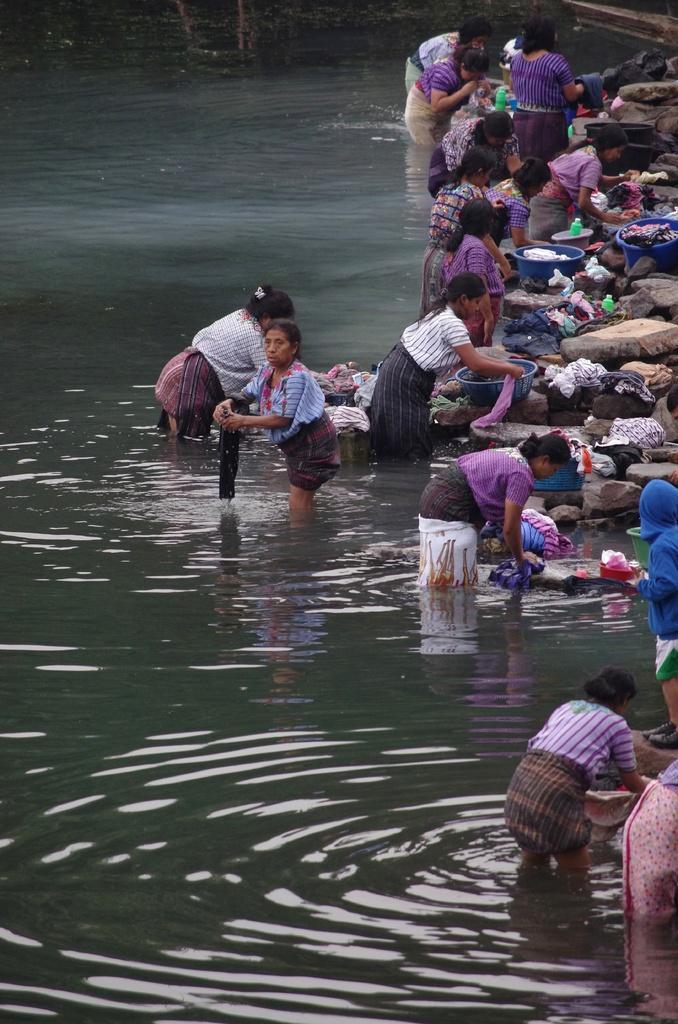How would you summarize this image in a sentence or two? In the picture we can see few women are washing the clothes in the water and some of them are in the purple color clothes. 